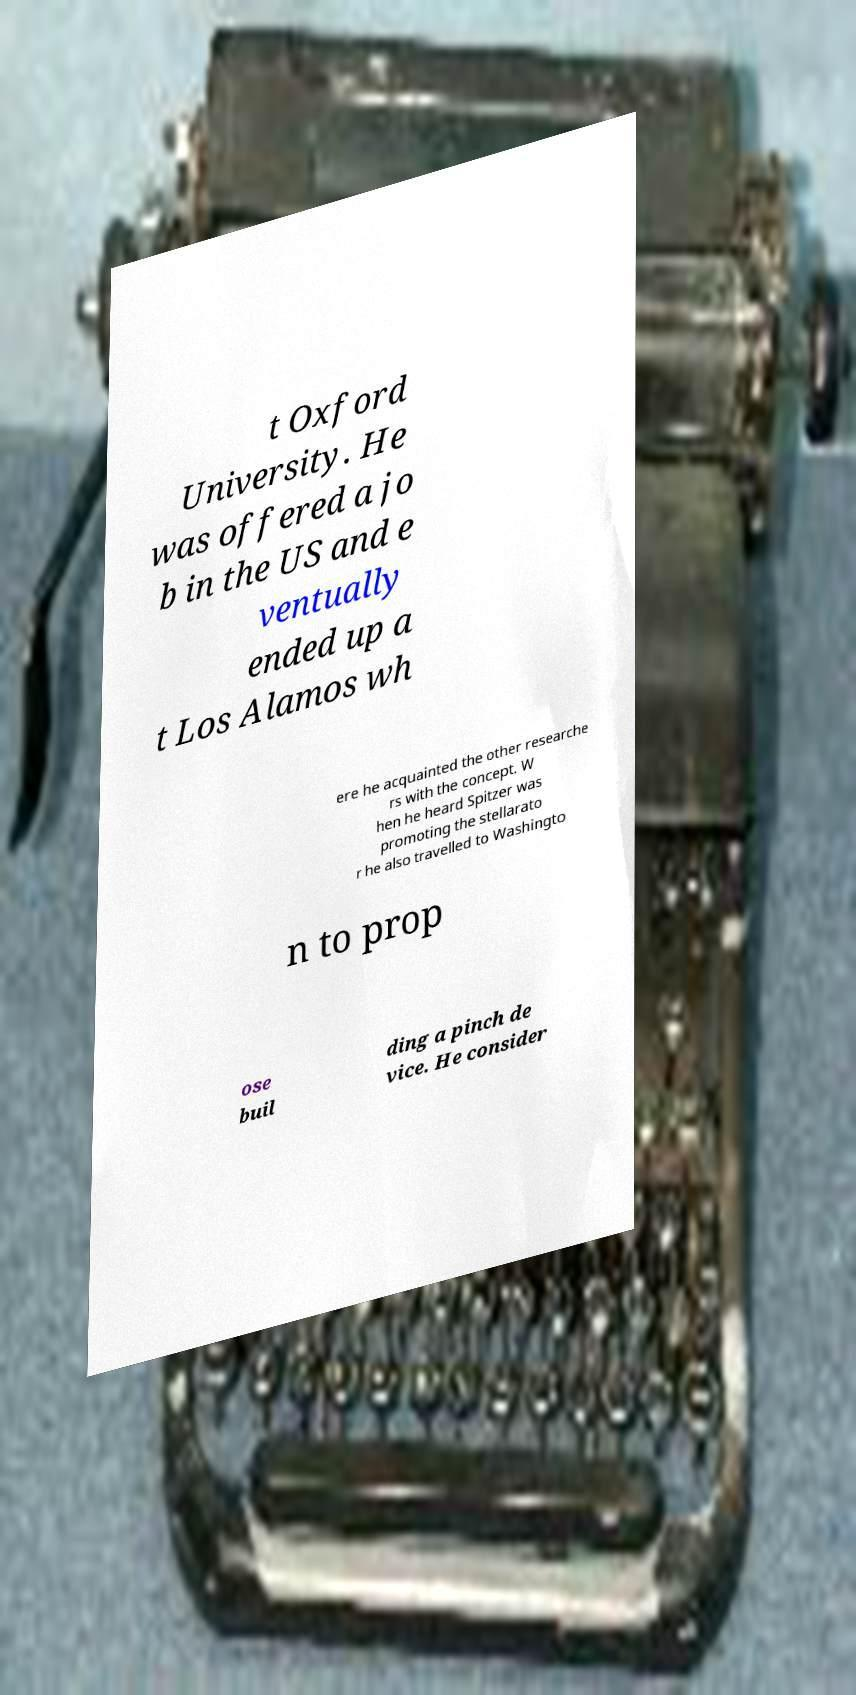For documentation purposes, I need the text within this image transcribed. Could you provide that? t Oxford University. He was offered a jo b in the US and e ventually ended up a t Los Alamos wh ere he acquainted the other researche rs with the concept. W hen he heard Spitzer was promoting the stellarato r he also travelled to Washingto n to prop ose buil ding a pinch de vice. He consider 